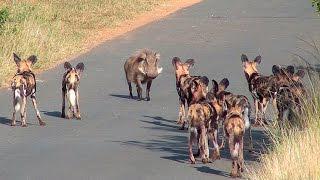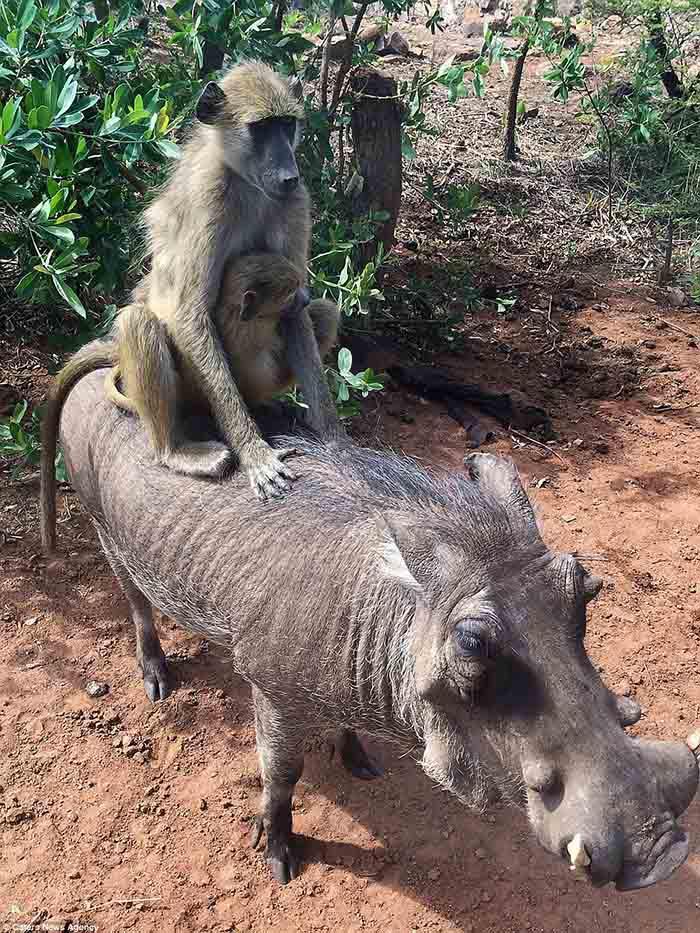The first image is the image on the left, the second image is the image on the right. Given the left and right images, does the statement "In one image, there is at least one animal on top of another one." hold true? Answer yes or no. Yes. 